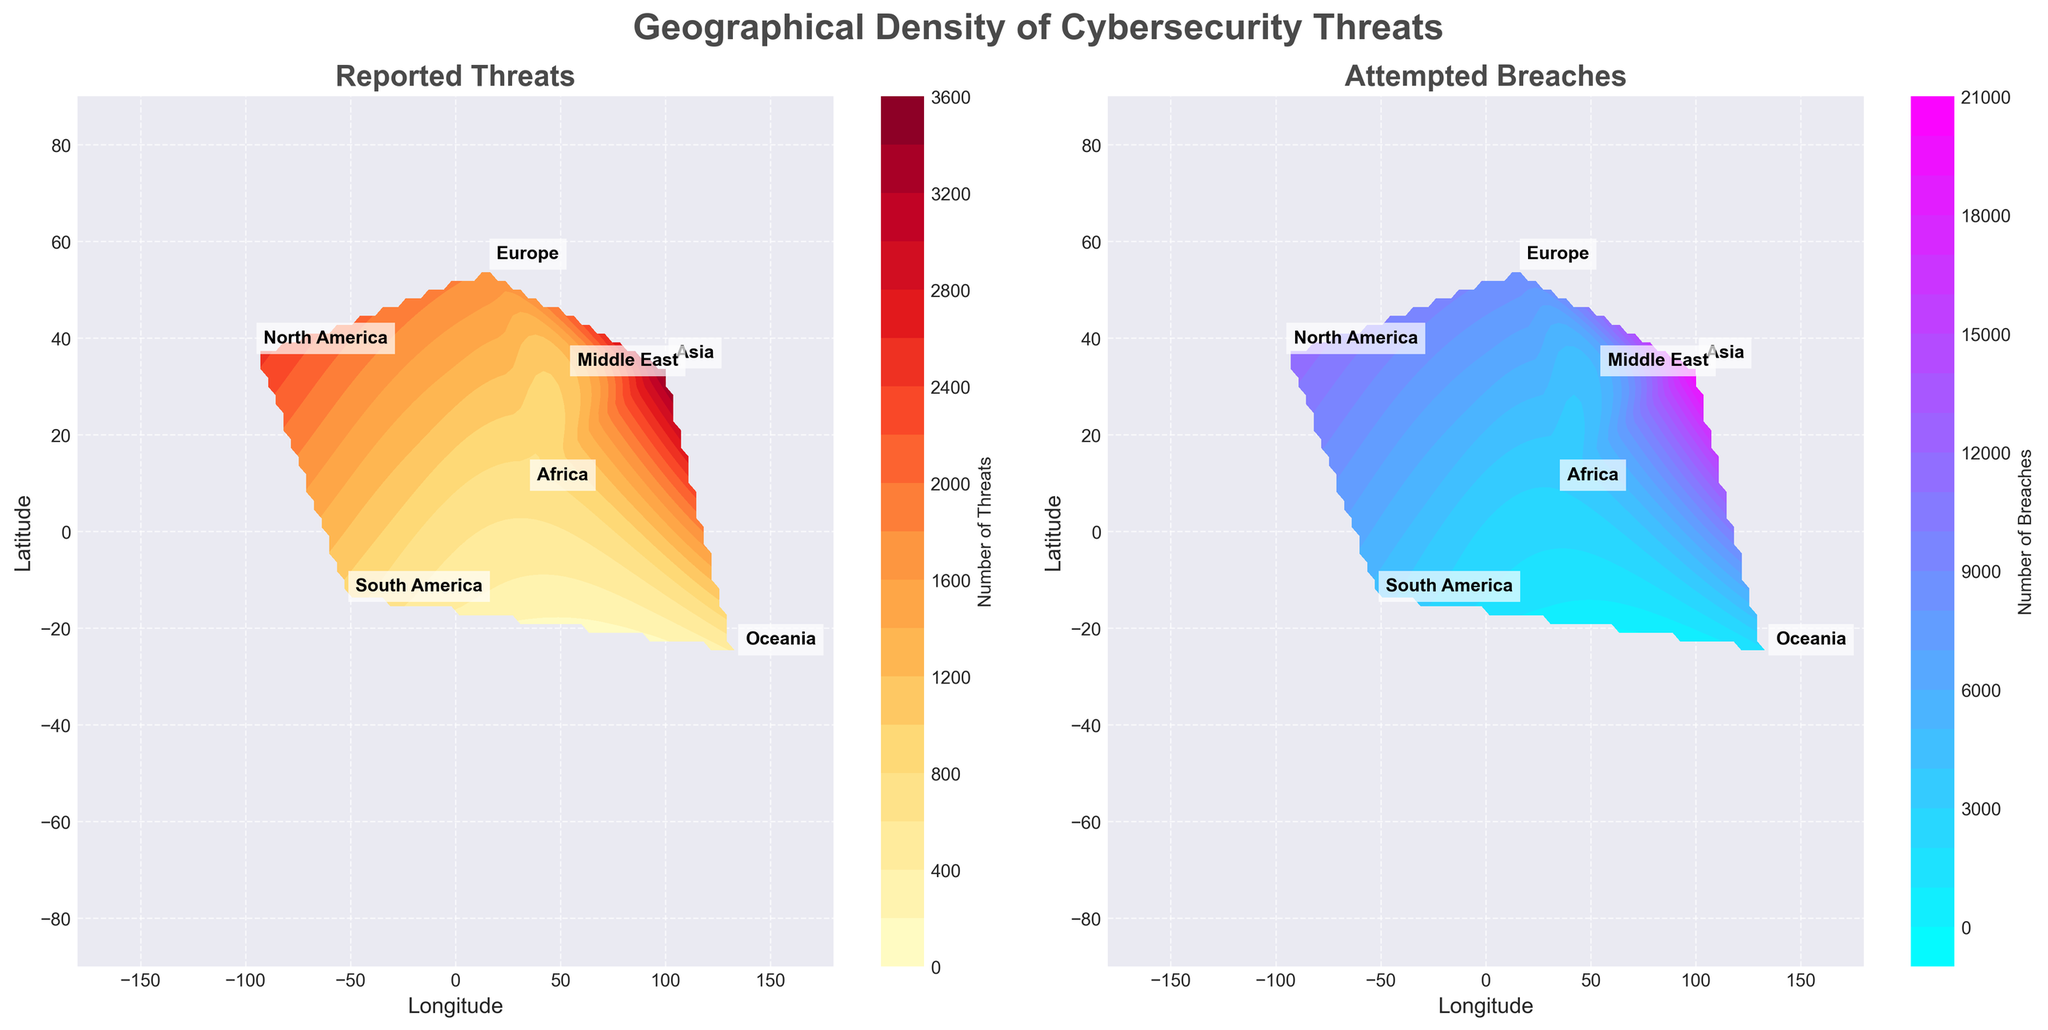What's the title of the figure? The title is prominently displayed at the top center of the figure. It reads "Geographical Density of Cybersecurity Threats".
Answer: Geographical Density of Cybersecurity Threats How many subplots are in the figure? The figure contains two subplots, positioned side by side.
Answer: 2 Which region has the highest number of reported threats? By examining the colors in the "Reported Threats" subplot, Asia has the most intense color shade, indicating the highest number of reported threats.
Answer: Asia Which region reports more attempted breaches: Europe or Oceania? By comparing the shades in the "Attempted Breaches" subplot, Europe has a significantly darker shade compared to Oceania, indicating more attempted breaches.
Answer: Europe In the "Reported Threats" subplot, which two regions have the closest intensity of reported threats? By examining the color shades, North America and Asia are the most intense, but Europe and the Middle East have the closest similar, slightly lighter shades.
Answer: Europe and Middle East What is the range of the latitude and longitude represented in both subplots? The x-axis (longitude) ranges from -180 to 180, and the y-axis (latitude) ranges from -90 to 90 in both subplots. This can be seen from the labeled axes.
Answer: -180 to 180 (longitude), -90 to 90 (latitude) How are the color scales different between the two subplots? The "Reported Threats" subplot uses a 'YlOrRd' colormap ranging from yellow to red, while the "Attempted Breaches" subplot uses a 'cool' colormap ranging from blue to pink.
Answer: Different colormaps ('YlOrRd' and 'cool') Which subplot has more regions annotated with their names? Both subplots have the same number of annotated regions as they share the same geographical labels. All 7 regions are labeled on both subplots.
Answer: Both subplots Which oceanic region has the fewest attempted breaches, according to the figure? Oceania is depicted with the lightest color intensity in the "Attempted Breaches" subplot compared to other regions.
Answer: Oceania 